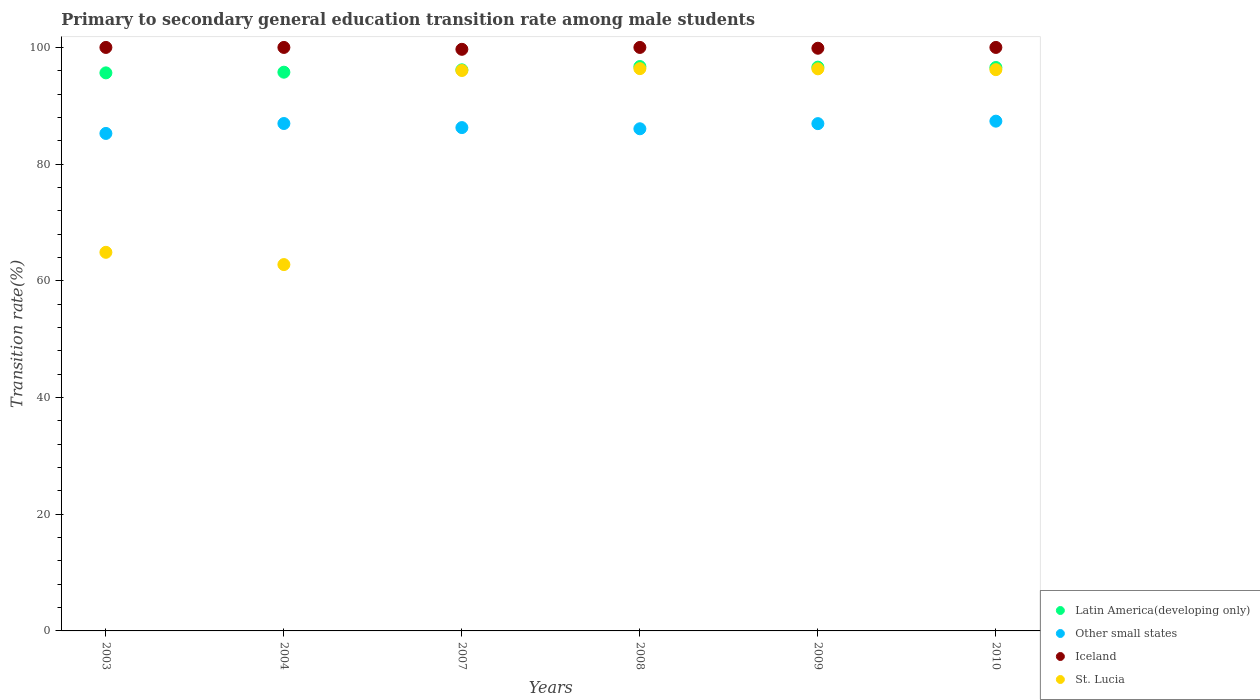What is the transition rate in Latin America(developing only) in 2003?
Your response must be concise. 95.64. Across all years, what is the maximum transition rate in Other small states?
Give a very brief answer. 87.36. Across all years, what is the minimum transition rate in St. Lucia?
Provide a short and direct response. 62.78. In which year was the transition rate in St. Lucia minimum?
Keep it short and to the point. 2004. What is the total transition rate in Other small states in the graph?
Offer a very short reply. 518.85. What is the difference between the transition rate in Iceland in 2004 and the transition rate in Latin America(developing only) in 2009?
Keep it short and to the point. 3.38. What is the average transition rate in Iceland per year?
Offer a terse response. 99.92. In the year 2004, what is the difference between the transition rate in Other small states and transition rate in Iceland?
Your answer should be very brief. -13.04. What is the ratio of the transition rate in Latin America(developing only) in 2003 to that in 2008?
Your answer should be very brief. 0.99. Is the difference between the transition rate in Other small states in 2003 and 2004 greater than the difference between the transition rate in Iceland in 2003 and 2004?
Provide a short and direct response. No. What is the difference between the highest and the second highest transition rate in Latin America(developing only)?
Give a very brief answer. 0.1. What is the difference between the highest and the lowest transition rate in Iceland?
Give a very brief answer. 0.32. In how many years, is the transition rate in St. Lucia greater than the average transition rate in St. Lucia taken over all years?
Offer a terse response. 4. Is it the case that in every year, the sum of the transition rate in Latin America(developing only) and transition rate in Iceland  is greater than the sum of transition rate in Other small states and transition rate in St. Lucia?
Offer a very short reply. No. Is it the case that in every year, the sum of the transition rate in Other small states and transition rate in Latin America(developing only)  is greater than the transition rate in St. Lucia?
Provide a succinct answer. Yes. Does the transition rate in Latin America(developing only) monotonically increase over the years?
Your answer should be compact. No. Is the transition rate in Latin America(developing only) strictly less than the transition rate in Other small states over the years?
Your answer should be very brief. No. How many dotlines are there?
Make the answer very short. 4. How many years are there in the graph?
Your answer should be compact. 6. Does the graph contain any zero values?
Offer a very short reply. No. Does the graph contain grids?
Offer a terse response. No. Where does the legend appear in the graph?
Your response must be concise. Bottom right. What is the title of the graph?
Your answer should be very brief. Primary to secondary general education transition rate among male students. Does "Marshall Islands" appear as one of the legend labels in the graph?
Offer a terse response. No. What is the label or title of the X-axis?
Your response must be concise. Years. What is the label or title of the Y-axis?
Your answer should be compact. Transition rate(%). What is the Transition rate(%) in Latin America(developing only) in 2003?
Make the answer very short. 95.64. What is the Transition rate(%) in Other small states in 2003?
Provide a succinct answer. 85.26. What is the Transition rate(%) of St. Lucia in 2003?
Offer a very short reply. 64.89. What is the Transition rate(%) of Latin America(developing only) in 2004?
Your response must be concise. 95.76. What is the Transition rate(%) in Other small states in 2004?
Your answer should be very brief. 86.96. What is the Transition rate(%) of St. Lucia in 2004?
Ensure brevity in your answer.  62.78. What is the Transition rate(%) in Latin America(developing only) in 2007?
Ensure brevity in your answer.  96.16. What is the Transition rate(%) of Other small states in 2007?
Your answer should be very brief. 86.26. What is the Transition rate(%) of Iceland in 2007?
Your answer should be compact. 99.68. What is the Transition rate(%) in St. Lucia in 2007?
Offer a terse response. 96.05. What is the Transition rate(%) in Latin America(developing only) in 2008?
Your response must be concise. 96.73. What is the Transition rate(%) of Other small states in 2008?
Provide a short and direct response. 86.06. What is the Transition rate(%) of St. Lucia in 2008?
Offer a very short reply. 96.37. What is the Transition rate(%) in Latin America(developing only) in 2009?
Offer a very short reply. 96.62. What is the Transition rate(%) in Other small states in 2009?
Make the answer very short. 86.94. What is the Transition rate(%) of Iceland in 2009?
Give a very brief answer. 99.86. What is the Transition rate(%) in St. Lucia in 2009?
Ensure brevity in your answer.  96.33. What is the Transition rate(%) in Latin America(developing only) in 2010?
Your answer should be compact. 96.56. What is the Transition rate(%) of Other small states in 2010?
Offer a terse response. 87.36. What is the Transition rate(%) of Iceland in 2010?
Provide a short and direct response. 100. What is the Transition rate(%) of St. Lucia in 2010?
Keep it short and to the point. 96.19. Across all years, what is the maximum Transition rate(%) of Latin America(developing only)?
Ensure brevity in your answer.  96.73. Across all years, what is the maximum Transition rate(%) of Other small states?
Your response must be concise. 87.36. Across all years, what is the maximum Transition rate(%) of St. Lucia?
Provide a short and direct response. 96.37. Across all years, what is the minimum Transition rate(%) in Latin America(developing only)?
Your response must be concise. 95.64. Across all years, what is the minimum Transition rate(%) in Other small states?
Ensure brevity in your answer.  85.26. Across all years, what is the minimum Transition rate(%) of Iceland?
Ensure brevity in your answer.  99.68. Across all years, what is the minimum Transition rate(%) in St. Lucia?
Your answer should be very brief. 62.78. What is the total Transition rate(%) of Latin America(developing only) in the graph?
Make the answer very short. 577.47. What is the total Transition rate(%) of Other small states in the graph?
Offer a very short reply. 518.85. What is the total Transition rate(%) of Iceland in the graph?
Your answer should be very brief. 599.54. What is the total Transition rate(%) of St. Lucia in the graph?
Keep it short and to the point. 512.61. What is the difference between the Transition rate(%) of Latin America(developing only) in 2003 and that in 2004?
Give a very brief answer. -0.12. What is the difference between the Transition rate(%) in Other small states in 2003 and that in 2004?
Provide a succinct answer. -1.7. What is the difference between the Transition rate(%) of Iceland in 2003 and that in 2004?
Provide a short and direct response. 0. What is the difference between the Transition rate(%) in St. Lucia in 2003 and that in 2004?
Keep it short and to the point. 2.1. What is the difference between the Transition rate(%) in Latin America(developing only) in 2003 and that in 2007?
Your answer should be compact. -0.52. What is the difference between the Transition rate(%) of Other small states in 2003 and that in 2007?
Ensure brevity in your answer.  -1. What is the difference between the Transition rate(%) in Iceland in 2003 and that in 2007?
Your answer should be very brief. 0.32. What is the difference between the Transition rate(%) in St. Lucia in 2003 and that in 2007?
Your answer should be compact. -31.16. What is the difference between the Transition rate(%) of Latin America(developing only) in 2003 and that in 2008?
Offer a terse response. -1.09. What is the difference between the Transition rate(%) in Other small states in 2003 and that in 2008?
Keep it short and to the point. -0.8. What is the difference between the Transition rate(%) of Iceland in 2003 and that in 2008?
Provide a succinct answer. 0. What is the difference between the Transition rate(%) of St. Lucia in 2003 and that in 2008?
Offer a terse response. -31.48. What is the difference between the Transition rate(%) in Latin America(developing only) in 2003 and that in 2009?
Offer a terse response. -0.98. What is the difference between the Transition rate(%) in Other small states in 2003 and that in 2009?
Your answer should be very brief. -1.68. What is the difference between the Transition rate(%) of Iceland in 2003 and that in 2009?
Provide a short and direct response. 0.14. What is the difference between the Transition rate(%) in St. Lucia in 2003 and that in 2009?
Your answer should be very brief. -31.45. What is the difference between the Transition rate(%) in Latin America(developing only) in 2003 and that in 2010?
Provide a short and direct response. -0.92. What is the difference between the Transition rate(%) in Other small states in 2003 and that in 2010?
Keep it short and to the point. -2.1. What is the difference between the Transition rate(%) in St. Lucia in 2003 and that in 2010?
Your answer should be very brief. -31.31. What is the difference between the Transition rate(%) of Latin America(developing only) in 2004 and that in 2007?
Give a very brief answer. -0.4. What is the difference between the Transition rate(%) of Other small states in 2004 and that in 2007?
Make the answer very short. 0.7. What is the difference between the Transition rate(%) in Iceland in 2004 and that in 2007?
Your response must be concise. 0.32. What is the difference between the Transition rate(%) of St. Lucia in 2004 and that in 2007?
Your answer should be very brief. -33.26. What is the difference between the Transition rate(%) in Latin America(developing only) in 2004 and that in 2008?
Provide a succinct answer. -0.97. What is the difference between the Transition rate(%) in Other small states in 2004 and that in 2008?
Keep it short and to the point. 0.9. What is the difference between the Transition rate(%) of St. Lucia in 2004 and that in 2008?
Offer a terse response. -33.58. What is the difference between the Transition rate(%) of Latin America(developing only) in 2004 and that in 2009?
Your answer should be compact. -0.87. What is the difference between the Transition rate(%) of Iceland in 2004 and that in 2009?
Make the answer very short. 0.14. What is the difference between the Transition rate(%) in St. Lucia in 2004 and that in 2009?
Your response must be concise. -33.55. What is the difference between the Transition rate(%) in Latin America(developing only) in 2004 and that in 2010?
Provide a succinct answer. -0.8. What is the difference between the Transition rate(%) in Other small states in 2004 and that in 2010?
Your response must be concise. -0.4. What is the difference between the Transition rate(%) in Iceland in 2004 and that in 2010?
Your answer should be compact. 0. What is the difference between the Transition rate(%) of St. Lucia in 2004 and that in 2010?
Give a very brief answer. -33.41. What is the difference between the Transition rate(%) in Latin America(developing only) in 2007 and that in 2008?
Make the answer very short. -0.57. What is the difference between the Transition rate(%) in Other small states in 2007 and that in 2008?
Your response must be concise. 0.2. What is the difference between the Transition rate(%) in Iceland in 2007 and that in 2008?
Make the answer very short. -0.32. What is the difference between the Transition rate(%) in St. Lucia in 2007 and that in 2008?
Give a very brief answer. -0.32. What is the difference between the Transition rate(%) in Latin America(developing only) in 2007 and that in 2009?
Give a very brief answer. -0.46. What is the difference between the Transition rate(%) in Other small states in 2007 and that in 2009?
Your answer should be very brief. -0.68. What is the difference between the Transition rate(%) in Iceland in 2007 and that in 2009?
Your answer should be very brief. -0.18. What is the difference between the Transition rate(%) in St. Lucia in 2007 and that in 2009?
Ensure brevity in your answer.  -0.29. What is the difference between the Transition rate(%) of Latin America(developing only) in 2007 and that in 2010?
Give a very brief answer. -0.4. What is the difference between the Transition rate(%) of Other small states in 2007 and that in 2010?
Provide a short and direct response. -1.1. What is the difference between the Transition rate(%) in Iceland in 2007 and that in 2010?
Provide a succinct answer. -0.32. What is the difference between the Transition rate(%) of St. Lucia in 2007 and that in 2010?
Make the answer very short. -0.15. What is the difference between the Transition rate(%) in Latin America(developing only) in 2008 and that in 2009?
Make the answer very short. 0.1. What is the difference between the Transition rate(%) in Other small states in 2008 and that in 2009?
Offer a very short reply. -0.88. What is the difference between the Transition rate(%) of Iceland in 2008 and that in 2009?
Ensure brevity in your answer.  0.14. What is the difference between the Transition rate(%) of St. Lucia in 2008 and that in 2009?
Provide a short and direct response. 0.03. What is the difference between the Transition rate(%) of Latin America(developing only) in 2008 and that in 2010?
Your answer should be very brief. 0.17. What is the difference between the Transition rate(%) in Other small states in 2008 and that in 2010?
Provide a succinct answer. -1.3. What is the difference between the Transition rate(%) of Iceland in 2008 and that in 2010?
Ensure brevity in your answer.  0. What is the difference between the Transition rate(%) of St. Lucia in 2008 and that in 2010?
Offer a terse response. 0.17. What is the difference between the Transition rate(%) of Latin America(developing only) in 2009 and that in 2010?
Ensure brevity in your answer.  0.06. What is the difference between the Transition rate(%) of Other small states in 2009 and that in 2010?
Your answer should be compact. -0.42. What is the difference between the Transition rate(%) in Iceland in 2009 and that in 2010?
Give a very brief answer. -0.14. What is the difference between the Transition rate(%) in St. Lucia in 2009 and that in 2010?
Your answer should be very brief. 0.14. What is the difference between the Transition rate(%) in Latin America(developing only) in 2003 and the Transition rate(%) in Other small states in 2004?
Your answer should be very brief. 8.68. What is the difference between the Transition rate(%) in Latin America(developing only) in 2003 and the Transition rate(%) in Iceland in 2004?
Offer a very short reply. -4.36. What is the difference between the Transition rate(%) of Latin America(developing only) in 2003 and the Transition rate(%) of St. Lucia in 2004?
Keep it short and to the point. 32.86. What is the difference between the Transition rate(%) of Other small states in 2003 and the Transition rate(%) of Iceland in 2004?
Offer a very short reply. -14.74. What is the difference between the Transition rate(%) in Other small states in 2003 and the Transition rate(%) in St. Lucia in 2004?
Make the answer very short. 22.48. What is the difference between the Transition rate(%) in Iceland in 2003 and the Transition rate(%) in St. Lucia in 2004?
Your response must be concise. 37.22. What is the difference between the Transition rate(%) of Latin America(developing only) in 2003 and the Transition rate(%) of Other small states in 2007?
Your answer should be very brief. 9.38. What is the difference between the Transition rate(%) in Latin America(developing only) in 2003 and the Transition rate(%) in Iceland in 2007?
Offer a very short reply. -4.04. What is the difference between the Transition rate(%) in Latin America(developing only) in 2003 and the Transition rate(%) in St. Lucia in 2007?
Your response must be concise. -0.41. What is the difference between the Transition rate(%) of Other small states in 2003 and the Transition rate(%) of Iceland in 2007?
Make the answer very short. -14.42. What is the difference between the Transition rate(%) of Other small states in 2003 and the Transition rate(%) of St. Lucia in 2007?
Provide a short and direct response. -10.79. What is the difference between the Transition rate(%) in Iceland in 2003 and the Transition rate(%) in St. Lucia in 2007?
Offer a terse response. 3.95. What is the difference between the Transition rate(%) of Latin America(developing only) in 2003 and the Transition rate(%) of Other small states in 2008?
Keep it short and to the point. 9.58. What is the difference between the Transition rate(%) in Latin America(developing only) in 2003 and the Transition rate(%) in Iceland in 2008?
Keep it short and to the point. -4.36. What is the difference between the Transition rate(%) in Latin America(developing only) in 2003 and the Transition rate(%) in St. Lucia in 2008?
Provide a short and direct response. -0.73. What is the difference between the Transition rate(%) of Other small states in 2003 and the Transition rate(%) of Iceland in 2008?
Ensure brevity in your answer.  -14.74. What is the difference between the Transition rate(%) of Other small states in 2003 and the Transition rate(%) of St. Lucia in 2008?
Offer a terse response. -11.11. What is the difference between the Transition rate(%) of Iceland in 2003 and the Transition rate(%) of St. Lucia in 2008?
Offer a terse response. 3.63. What is the difference between the Transition rate(%) in Latin America(developing only) in 2003 and the Transition rate(%) in Other small states in 2009?
Make the answer very short. 8.7. What is the difference between the Transition rate(%) in Latin America(developing only) in 2003 and the Transition rate(%) in Iceland in 2009?
Make the answer very short. -4.22. What is the difference between the Transition rate(%) of Latin America(developing only) in 2003 and the Transition rate(%) of St. Lucia in 2009?
Provide a succinct answer. -0.69. What is the difference between the Transition rate(%) of Other small states in 2003 and the Transition rate(%) of Iceland in 2009?
Provide a succinct answer. -14.6. What is the difference between the Transition rate(%) in Other small states in 2003 and the Transition rate(%) in St. Lucia in 2009?
Your answer should be compact. -11.07. What is the difference between the Transition rate(%) of Iceland in 2003 and the Transition rate(%) of St. Lucia in 2009?
Make the answer very short. 3.67. What is the difference between the Transition rate(%) in Latin America(developing only) in 2003 and the Transition rate(%) in Other small states in 2010?
Your answer should be very brief. 8.28. What is the difference between the Transition rate(%) of Latin America(developing only) in 2003 and the Transition rate(%) of Iceland in 2010?
Keep it short and to the point. -4.36. What is the difference between the Transition rate(%) of Latin America(developing only) in 2003 and the Transition rate(%) of St. Lucia in 2010?
Offer a terse response. -0.55. What is the difference between the Transition rate(%) in Other small states in 2003 and the Transition rate(%) in Iceland in 2010?
Keep it short and to the point. -14.74. What is the difference between the Transition rate(%) of Other small states in 2003 and the Transition rate(%) of St. Lucia in 2010?
Ensure brevity in your answer.  -10.93. What is the difference between the Transition rate(%) in Iceland in 2003 and the Transition rate(%) in St. Lucia in 2010?
Make the answer very short. 3.81. What is the difference between the Transition rate(%) in Latin America(developing only) in 2004 and the Transition rate(%) in Other small states in 2007?
Give a very brief answer. 9.49. What is the difference between the Transition rate(%) of Latin America(developing only) in 2004 and the Transition rate(%) of Iceland in 2007?
Your answer should be compact. -3.92. What is the difference between the Transition rate(%) in Latin America(developing only) in 2004 and the Transition rate(%) in St. Lucia in 2007?
Give a very brief answer. -0.29. What is the difference between the Transition rate(%) of Other small states in 2004 and the Transition rate(%) of Iceland in 2007?
Provide a short and direct response. -12.72. What is the difference between the Transition rate(%) of Other small states in 2004 and the Transition rate(%) of St. Lucia in 2007?
Offer a terse response. -9.09. What is the difference between the Transition rate(%) of Iceland in 2004 and the Transition rate(%) of St. Lucia in 2007?
Keep it short and to the point. 3.95. What is the difference between the Transition rate(%) of Latin America(developing only) in 2004 and the Transition rate(%) of Other small states in 2008?
Provide a succinct answer. 9.7. What is the difference between the Transition rate(%) of Latin America(developing only) in 2004 and the Transition rate(%) of Iceland in 2008?
Keep it short and to the point. -4.24. What is the difference between the Transition rate(%) in Latin America(developing only) in 2004 and the Transition rate(%) in St. Lucia in 2008?
Give a very brief answer. -0.61. What is the difference between the Transition rate(%) in Other small states in 2004 and the Transition rate(%) in Iceland in 2008?
Give a very brief answer. -13.04. What is the difference between the Transition rate(%) of Other small states in 2004 and the Transition rate(%) of St. Lucia in 2008?
Give a very brief answer. -9.4. What is the difference between the Transition rate(%) of Iceland in 2004 and the Transition rate(%) of St. Lucia in 2008?
Offer a very short reply. 3.63. What is the difference between the Transition rate(%) in Latin America(developing only) in 2004 and the Transition rate(%) in Other small states in 2009?
Your answer should be very brief. 8.82. What is the difference between the Transition rate(%) of Latin America(developing only) in 2004 and the Transition rate(%) of Iceland in 2009?
Your answer should be very brief. -4.11. What is the difference between the Transition rate(%) in Latin America(developing only) in 2004 and the Transition rate(%) in St. Lucia in 2009?
Your response must be concise. -0.58. What is the difference between the Transition rate(%) in Other small states in 2004 and the Transition rate(%) in Iceland in 2009?
Ensure brevity in your answer.  -12.9. What is the difference between the Transition rate(%) of Other small states in 2004 and the Transition rate(%) of St. Lucia in 2009?
Your response must be concise. -9.37. What is the difference between the Transition rate(%) of Iceland in 2004 and the Transition rate(%) of St. Lucia in 2009?
Your answer should be very brief. 3.67. What is the difference between the Transition rate(%) of Latin America(developing only) in 2004 and the Transition rate(%) of Other small states in 2010?
Offer a very short reply. 8.39. What is the difference between the Transition rate(%) in Latin America(developing only) in 2004 and the Transition rate(%) in Iceland in 2010?
Provide a succinct answer. -4.24. What is the difference between the Transition rate(%) in Latin America(developing only) in 2004 and the Transition rate(%) in St. Lucia in 2010?
Offer a very short reply. -0.44. What is the difference between the Transition rate(%) of Other small states in 2004 and the Transition rate(%) of Iceland in 2010?
Your response must be concise. -13.04. What is the difference between the Transition rate(%) in Other small states in 2004 and the Transition rate(%) in St. Lucia in 2010?
Your answer should be very brief. -9.23. What is the difference between the Transition rate(%) in Iceland in 2004 and the Transition rate(%) in St. Lucia in 2010?
Give a very brief answer. 3.81. What is the difference between the Transition rate(%) in Latin America(developing only) in 2007 and the Transition rate(%) in Other small states in 2008?
Provide a succinct answer. 10.1. What is the difference between the Transition rate(%) of Latin America(developing only) in 2007 and the Transition rate(%) of Iceland in 2008?
Provide a succinct answer. -3.84. What is the difference between the Transition rate(%) in Latin America(developing only) in 2007 and the Transition rate(%) in St. Lucia in 2008?
Provide a succinct answer. -0.21. What is the difference between the Transition rate(%) of Other small states in 2007 and the Transition rate(%) of Iceland in 2008?
Give a very brief answer. -13.74. What is the difference between the Transition rate(%) in Other small states in 2007 and the Transition rate(%) in St. Lucia in 2008?
Ensure brevity in your answer.  -10.1. What is the difference between the Transition rate(%) of Iceland in 2007 and the Transition rate(%) of St. Lucia in 2008?
Provide a short and direct response. 3.31. What is the difference between the Transition rate(%) of Latin America(developing only) in 2007 and the Transition rate(%) of Other small states in 2009?
Keep it short and to the point. 9.22. What is the difference between the Transition rate(%) of Latin America(developing only) in 2007 and the Transition rate(%) of Iceland in 2009?
Ensure brevity in your answer.  -3.7. What is the difference between the Transition rate(%) of Latin America(developing only) in 2007 and the Transition rate(%) of St. Lucia in 2009?
Make the answer very short. -0.17. What is the difference between the Transition rate(%) of Other small states in 2007 and the Transition rate(%) of Iceland in 2009?
Ensure brevity in your answer.  -13.6. What is the difference between the Transition rate(%) of Other small states in 2007 and the Transition rate(%) of St. Lucia in 2009?
Make the answer very short. -10.07. What is the difference between the Transition rate(%) in Iceland in 2007 and the Transition rate(%) in St. Lucia in 2009?
Keep it short and to the point. 3.34. What is the difference between the Transition rate(%) of Latin America(developing only) in 2007 and the Transition rate(%) of Other small states in 2010?
Offer a terse response. 8.8. What is the difference between the Transition rate(%) in Latin America(developing only) in 2007 and the Transition rate(%) in Iceland in 2010?
Keep it short and to the point. -3.84. What is the difference between the Transition rate(%) of Latin America(developing only) in 2007 and the Transition rate(%) of St. Lucia in 2010?
Your answer should be very brief. -0.03. What is the difference between the Transition rate(%) of Other small states in 2007 and the Transition rate(%) of Iceland in 2010?
Give a very brief answer. -13.74. What is the difference between the Transition rate(%) of Other small states in 2007 and the Transition rate(%) of St. Lucia in 2010?
Offer a very short reply. -9.93. What is the difference between the Transition rate(%) of Iceland in 2007 and the Transition rate(%) of St. Lucia in 2010?
Your answer should be compact. 3.48. What is the difference between the Transition rate(%) of Latin America(developing only) in 2008 and the Transition rate(%) of Other small states in 2009?
Offer a terse response. 9.79. What is the difference between the Transition rate(%) of Latin America(developing only) in 2008 and the Transition rate(%) of Iceland in 2009?
Your response must be concise. -3.13. What is the difference between the Transition rate(%) in Latin America(developing only) in 2008 and the Transition rate(%) in St. Lucia in 2009?
Give a very brief answer. 0.39. What is the difference between the Transition rate(%) of Other small states in 2008 and the Transition rate(%) of Iceland in 2009?
Your response must be concise. -13.8. What is the difference between the Transition rate(%) of Other small states in 2008 and the Transition rate(%) of St. Lucia in 2009?
Give a very brief answer. -10.27. What is the difference between the Transition rate(%) of Iceland in 2008 and the Transition rate(%) of St. Lucia in 2009?
Offer a very short reply. 3.67. What is the difference between the Transition rate(%) in Latin America(developing only) in 2008 and the Transition rate(%) in Other small states in 2010?
Provide a short and direct response. 9.36. What is the difference between the Transition rate(%) of Latin America(developing only) in 2008 and the Transition rate(%) of Iceland in 2010?
Keep it short and to the point. -3.27. What is the difference between the Transition rate(%) in Latin America(developing only) in 2008 and the Transition rate(%) in St. Lucia in 2010?
Offer a very short reply. 0.53. What is the difference between the Transition rate(%) in Other small states in 2008 and the Transition rate(%) in Iceland in 2010?
Provide a short and direct response. -13.94. What is the difference between the Transition rate(%) of Other small states in 2008 and the Transition rate(%) of St. Lucia in 2010?
Keep it short and to the point. -10.13. What is the difference between the Transition rate(%) in Iceland in 2008 and the Transition rate(%) in St. Lucia in 2010?
Offer a terse response. 3.81. What is the difference between the Transition rate(%) of Latin America(developing only) in 2009 and the Transition rate(%) of Other small states in 2010?
Keep it short and to the point. 9.26. What is the difference between the Transition rate(%) in Latin America(developing only) in 2009 and the Transition rate(%) in Iceland in 2010?
Give a very brief answer. -3.38. What is the difference between the Transition rate(%) of Latin America(developing only) in 2009 and the Transition rate(%) of St. Lucia in 2010?
Your response must be concise. 0.43. What is the difference between the Transition rate(%) of Other small states in 2009 and the Transition rate(%) of Iceland in 2010?
Keep it short and to the point. -13.06. What is the difference between the Transition rate(%) of Other small states in 2009 and the Transition rate(%) of St. Lucia in 2010?
Keep it short and to the point. -9.25. What is the difference between the Transition rate(%) of Iceland in 2009 and the Transition rate(%) of St. Lucia in 2010?
Offer a very short reply. 3.67. What is the average Transition rate(%) of Latin America(developing only) per year?
Offer a terse response. 96.24. What is the average Transition rate(%) in Other small states per year?
Your response must be concise. 86.47. What is the average Transition rate(%) in Iceland per year?
Your response must be concise. 99.92. What is the average Transition rate(%) in St. Lucia per year?
Give a very brief answer. 85.43. In the year 2003, what is the difference between the Transition rate(%) of Latin America(developing only) and Transition rate(%) of Other small states?
Ensure brevity in your answer.  10.38. In the year 2003, what is the difference between the Transition rate(%) of Latin America(developing only) and Transition rate(%) of Iceland?
Make the answer very short. -4.36. In the year 2003, what is the difference between the Transition rate(%) of Latin America(developing only) and Transition rate(%) of St. Lucia?
Ensure brevity in your answer.  30.75. In the year 2003, what is the difference between the Transition rate(%) in Other small states and Transition rate(%) in Iceland?
Your answer should be compact. -14.74. In the year 2003, what is the difference between the Transition rate(%) of Other small states and Transition rate(%) of St. Lucia?
Provide a short and direct response. 20.37. In the year 2003, what is the difference between the Transition rate(%) in Iceland and Transition rate(%) in St. Lucia?
Give a very brief answer. 35.11. In the year 2004, what is the difference between the Transition rate(%) of Latin America(developing only) and Transition rate(%) of Other small states?
Your answer should be very brief. 8.8. In the year 2004, what is the difference between the Transition rate(%) of Latin America(developing only) and Transition rate(%) of Iceland?
Your response must be concise. -4.24. In the year 2004, what is the difference between the Transition rate(%) in Latin America(developing only) and Transition rate(%) in St. Lucia?
Ensure brevity in your answer.  32.97. In the year 2004, what is the difference between the Transition rate(%) of Other small states and Transition rate(%) of Iceland?
Your response must be concise. -13.04. In the year 2004, what is the difference between the Transition rate(%) in Other small states and Transition rate(%) in St. Lucia?
Keep it short and to the point. 24.18. In the year 2004, what is the difference between the Transition rate(%) in Iceland and Transition rate(%) in St. Lucia?
Offer a very short reply. 37.22. In the year 2007, what is the difference between the Transition rate(%) in Latin America(developing only) and Transition rate(%) in Other small states?
Offer a terse response. 9.9. In the year 2007, what is the difference between the Transition rate(%) in Latin America(developing only) and Transition rate(%) in Iceland?
Your response must be concise. -3.52. In the year 2007, what is the difference between the Transition rate(%) of Latin America(developing only) and Transition rate(%) of St. Lucia?
Provide a succinct answer. 0.11. In the year 2007, what is the difference between the Transition rate(%) of Other small states and Transition rate(%) of Iceland?
Ensure brevity in your answer.  -13.41. In the year 2007, what is the difference between the Transition rate(%) in Other small states and Transition rate(%) in St. Lucia?
Offer a terse response. -9.78. In the year 2007, what is the difference between the Transition rate(%) in Iceland and Transition rate(%) in St. Lucia?
Provide a succinct answer. 3.63. In the year 2008, what is the difference between the Transition rate(%) of Latin America(developing only) and Transition rate(%) of Other small states?
Your answer should be very brief. 10.67. In the year 2008, what is the difference between the Transition rate(%) in Latin America(developing only) and Transition rate(%) in Iceland?
Offer a very short reply. -3.27. In the year 2008, what is the difference between the Transition rate(%) in Latin America(developing only) and Transition rate(%) in St. Lucia?
Keep it short and to the point. 0.36. In the year 2008, what is the difference between the Transition rate(%) in Other small states and Transition rate(%) in Iceland?
Your response must be concise. -13.94. In the year 2008, what is the difference between the Transition rate(%) of Other small states and Transition rate(%) of St. Lucia?
Offer a terse response. -10.31. In the year 2008, what is the difference between the Transition rate(%) of Iceland and Transition rate(%) of St. Lucia?
Give a very brief answer. 3.63. In the year 2009, what is the difference between the Transition rate(%) in Latin America(developing only) and Transition rate(%) in Other small states?
Provide a succinct answer. 9.68. In the year 2009, what is the difference between the Transition rate(%) of Latin America(developing only) and Transition rate(%) of Iceland?
Offer a very short reply. -3.24. In the year 2009, what is the difference between the Transition rate(%) of Latin America(developing only) and Transition rate(%) of St. Lucia?
Ensure brevity in your answer.  0.29. In the year 2009, what is the difference between the Transition rate(%) in Other small states and Transition rate(%) in Iceland?
Offer a very short reply. -12.92. In the year 2009, what is the difference between the Transition rate(%) in Other small states and Transition rate(%) in St. Lucia?
Ensure brevity in your answer.  -9.39. In the year 2009, what is the difference between the Transition rate(%) of Iceland and Transition rate(%) of St. Lucia?
Your answer should be very brief. 3.53. In the year 2010, what is the difference between the Transition rate(%) in Latin America(developing only) and Transition rate(%) in Other small states?
Your answer should be very brief. 9.2. In the year 2010, what is the difference between the Transition rate(%) in Latin America(developing only) and Transition rate(%) in Iceland?
Offer a terse response. -3.44. In the year 2010, what is the difference between the Transition rate(%) in Latin America(developing only) and Transition rate(%) in St. Lucia?
Your answer should be very brief. 0.37. In the year 2010, what is the difference between the Transition rate(%) in Other small states and Transition rate(%) in Iceland?
Your response must be concise. -12.64. In the year 2010, what is the difference between the Transition rate(%) in Other small states and Transition rate(%) in St. Lucia?
Provide a short and direct response. -8.83. In the year 2010, what is the difference between the Transition rate(%) in Iceland and Transition rate(%) in St. Lucia?
Keep it short and to the point. 3.81. What is the ratio of the Transition rate(%) of Other small states in 2003 to that in 2004?
Offer a terse response. 0.98. What is the ratio of the Transition rate(%) of Iceland in 2003 to that in 2004?
Your answer should be compact. 1. What is the ratio of the Transition rate(%) of St. Lucia in 2003 to that in 2004?
Provide a succinct answer. 1.03. What is the ratio of the Transition rate(%) of Other small states in 2003 to that in 2007?
Your response must be concise. 0.99. What is the ratio of the Transition rate(%) of Iceland in 2003 to that in 2007?
Your answer should be very brief. 1. What is the ratio of the Transition rate(%) of St. Lucia in 2003 to that in 2007?
Offer a very short reply. 0.68. What is the ratio of the Transition rate(%) of Latin America(developing only) in 2003 to that in 2008?
Keep it short and to the point. 0.99. What is the ratio of the Transition rate(%) of Other small states in 2003 to that in 2008?
Ensure brevity in your answer.  0.99. What is the ratio of the Transition rate(%) in Iceland in 2003 to that in 2008?
Your answer should be very brief. 1. What is the ratio of the Transition rate(%) of St. Lucia in 2003 to that in 2008?
Make the answer very short. 0.67. What is the ratio of the Transition rate(%) in Latin America(developing only) in 2003 to that in 2009?
Provide a short and direct response. 0.99. What is the ratio of the Transition rate(%) in Other small states in 2003 to that in 2009?
Keep it short and to the point. 0.98. What is the ratio of the Transition rate(%) of Iceland in 2003 to that in 2009?
Make the answer very short. 1. What is the ratio of the Transition rate(%) in St. Lucia in 2003 to that in 2009?
Give a very brief answer. 0.67. What is the ratio of the Transition rate(%) of Other small states in 2003 to that in 2010?
Offer a very short reply. 0.98. What is the ratio of the Transition rate(%) in St. Lucia in 2003 to that in 2010?
Provide a short and direct response. 0.67. What is the ratio of the Transition rate(%) in Latin America(developing only) in 2004 to that in 2007?
Your answer should be compact. 1. What is the ratio of the Transition rate(%) of St. Lucia in 2004 to that in 2007?
Give a very brief answer. 0.65. What is the ratio of the Transition rate(%) in Other small states in 2004 to that in 2008?
Give a very brief answer. 1.01. What is the ratio of the Transition rate(%) of St. Lucia in 2004 to that in 2008?
Offer a very short reply. 0.65. What is the ratio of the Transition rate(%) of St. Lucia in 2004 to that in 2009?
Your response must be concise. 0.65. What is the ratio of the Transition rate(%) of Latin America(developing only) in 2004 to that in 2010?
Keep it short and to the point. 0.99. What is the ratio of the Transition rate(%) in St. Lucia in 2004 to that in 2010?
Provide a short and direct response. 0.65. What is the ratio of the Transition rate(%) in Iceland in 2007 to that in 2008?
Provide a short and direct response. 1. What is the ratio of the Transition rate(%) of St. Lucia in 2007 to that in 2008?
Give a very brief answer. 1. What is the ratio of the Transition rate(%) in Other small states in 2007 to that in 2009?
Provide a succinct answer. 0.99. What is the ratio of the Transition rate(%) of Other small states in 2007 to that in 2010?
Offer a terse response. 0.99. What is the ratio of the Transition rate(%) of Iceland in 2007 to that in 2010?
Keep it short and to the point. 1. What is the ratio of the Transition rate(%) of St. Lucia in 2007 to that in 2010?
Your response must be concise. 1. What is the ratio of the Transition rate(%) of Other small states in 2008 to that in 2009?
Provide a succinct answer. 0.99. What is the ratio of the Transition rate(%) in Latin America(developing only) in 2008 to that in 2010?
Your response must be concise. 1. What is the ratio of the Transition rate(%) in Other small states in 2008 to that in 2010?
Provide a short and direct response. 0.99. What is the ratio of the Transition rate(%) in Latin America(developing only) in 2009 to that in 2010?
Offer a terse response. 1. What is the ratio of the Transition rate(%) of Other small states in 2009 to that in 2010?
Your answer should be compact. 1. What is the ratio of the Transition rate(%) of Iceland in 2009 to that in 2010?
Provide a short and direct response. 1. What is the ratio of the Transition rate(%) in St. Lucia in 2009 to that in 2010?
Provide a succinct answer. 1. What is the difference between the highest and the second highest Transition rate(%) of Latin America(developing only)?
Ensure brevity in your answer.  0.1. What is the difference between the highest and the second highest Transition rate(%) of Other small states?
Offer a very short reply. 0.4. What is the difference between the highest and the second highest Transition rate(%) of St. Lucia?
Offer a very short reply. 0.03. What is the difference between the highest and the lowest Transition rate(%) in Latin America(developing only)?
Give a very brief answer. 1.09. What is the difference between the highest and the lowest Transition rate(%) in Other small states?
Make the answer very short. 2.1. What is the difference between the highest and the lowest Transition rate(%) of Iceland?
Provide a short and direct response. 0.32. What is the difference between the highest and the lowest Transition rate(%) in St. Lucia?
Your answer should be very brief. 33.58. 